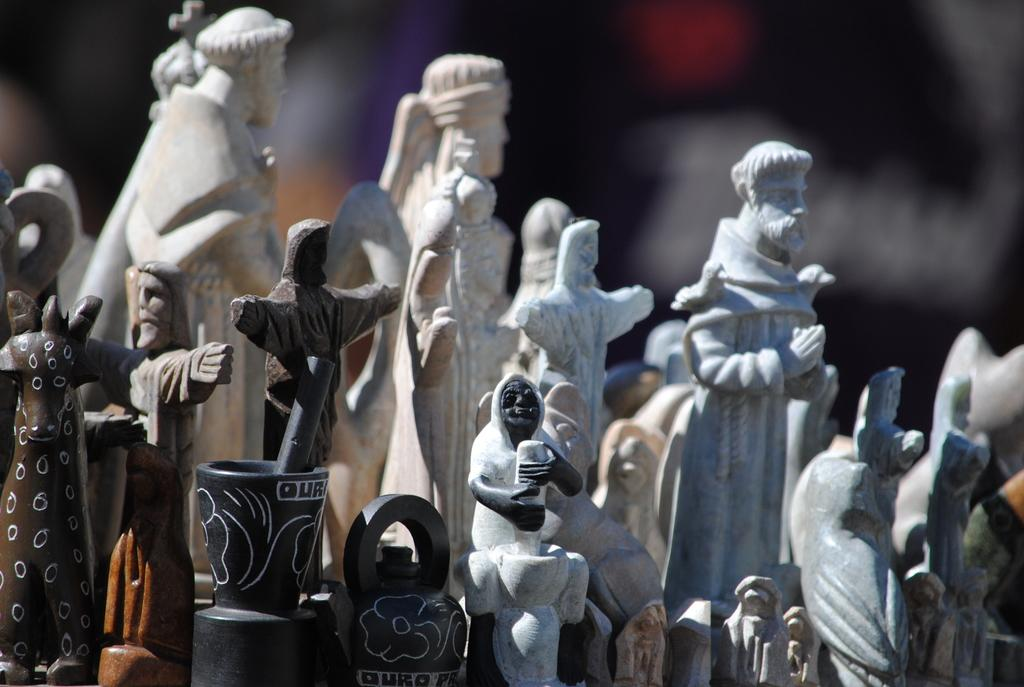What type of art is present in the image? There are sculptures in the image. Can you describe the background of the image? The background of the image is blurry. Where is the nest located in the image? There is no nest present in the image. What type of box can be seen in the image? There is no box present in the image. 